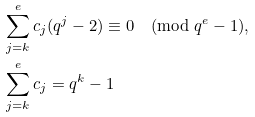<formula> <loc_0><loc_0><loc_500><loc_500>& \sum _ { j = k } ^ { e } c _ { j } ( q ^ { j } - 2 ) \equiv 0 \pmod { q ^ { e } - 1 } , \\ & \sum _ { j = k } ^ { e } c _ { j } = q ^ { k } - 1</formula> 